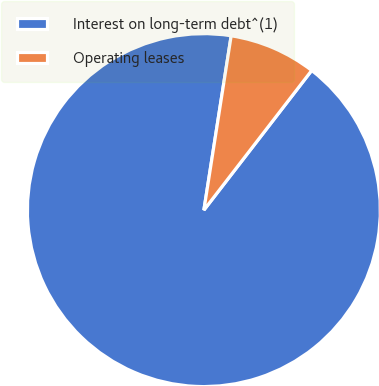Convert chart to OTSL. <chart><loc_0><loc_0><loc_500><loc_500><pie_chart><fcel>Interest on long-term debt^(1)<fcel>Operating leases<nl><fcel>92.01%<fcel>7.99%<nl></chart> 